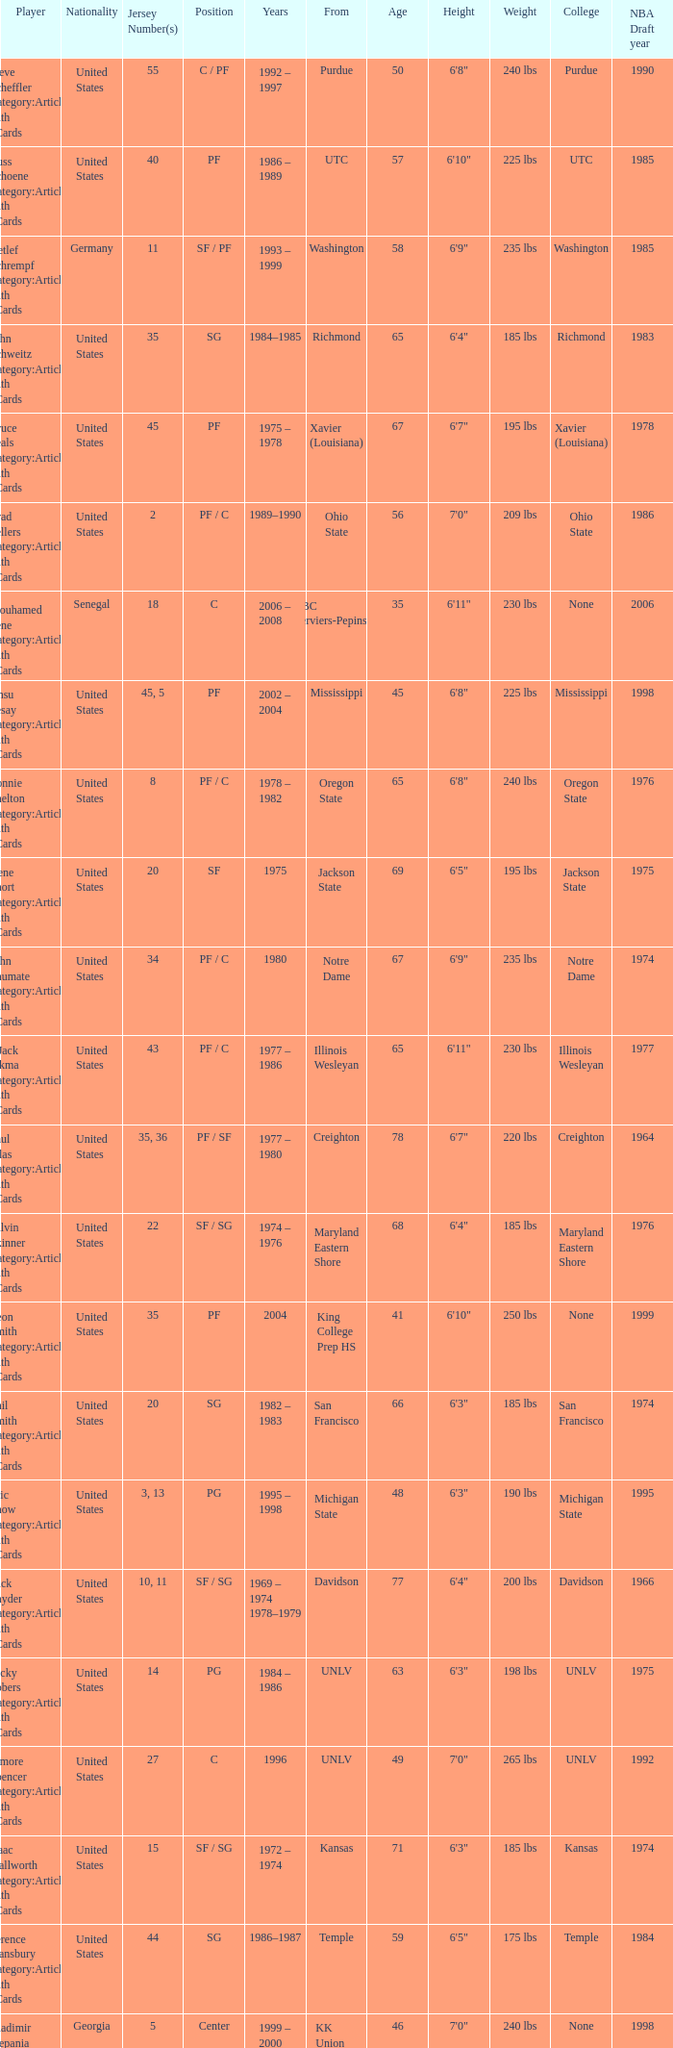Who wears the jersey number 20 and has the position of SG? Phil Smith Category:Articles with hCards, Jon Sundvold Category:Articles with hCards. 